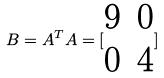<formula> <loc_0><loc_0><loc_500><loc_500>B = A ^ { T } A = [ \begin{matrix} 9 & 0 \\ 0 & 4 \end{matrix} ]</formula> 